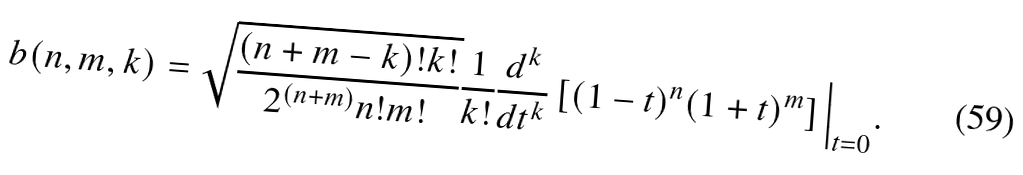Convert formula to latex. <formula><loc_0><loc_0><loc_500><loc_500>b ( n , m , k ) = \sqrt { \frac { ( n + m - k ) ! k ! } { 2 ^ { ( n + m ) } n ! m ! } } \frac { 1 } { k ! } \frac { d ^ { k } } { d t ^ { k } } \left [ ( 1 - t ) ^ { n } ( 1 + t ) ^ { m } \right ] \Big | _ { t = 0 } .</formula> 